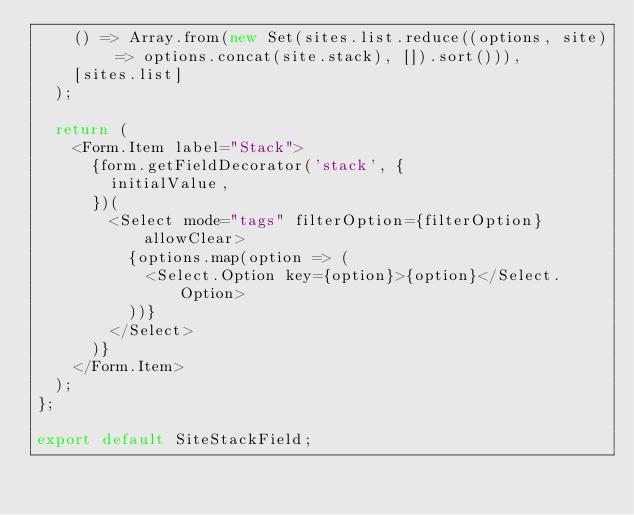Convert code to text. <code><loc_0><loc_0><loc_500><loc_500><_JavaScript_>    () => Array.from(new Set(sites.list.reduce((options, site) => options.concat(site.stack), []).sort())),
    [sites.list]
  );

  return (
    <Form.Item label="Stack">
      {form.getFieldDecorator('stack', {
        initialValue,
      })(
        <Select mode="tags" filterOption={filterOption} allowClear>
          {options.map(option => (
            <Select.Option key={option}>{option}</Select.Option>
          ))}
        </Select>
      )}
    </Form.Item>
  );
};

export default SiteStackField;
</code> 